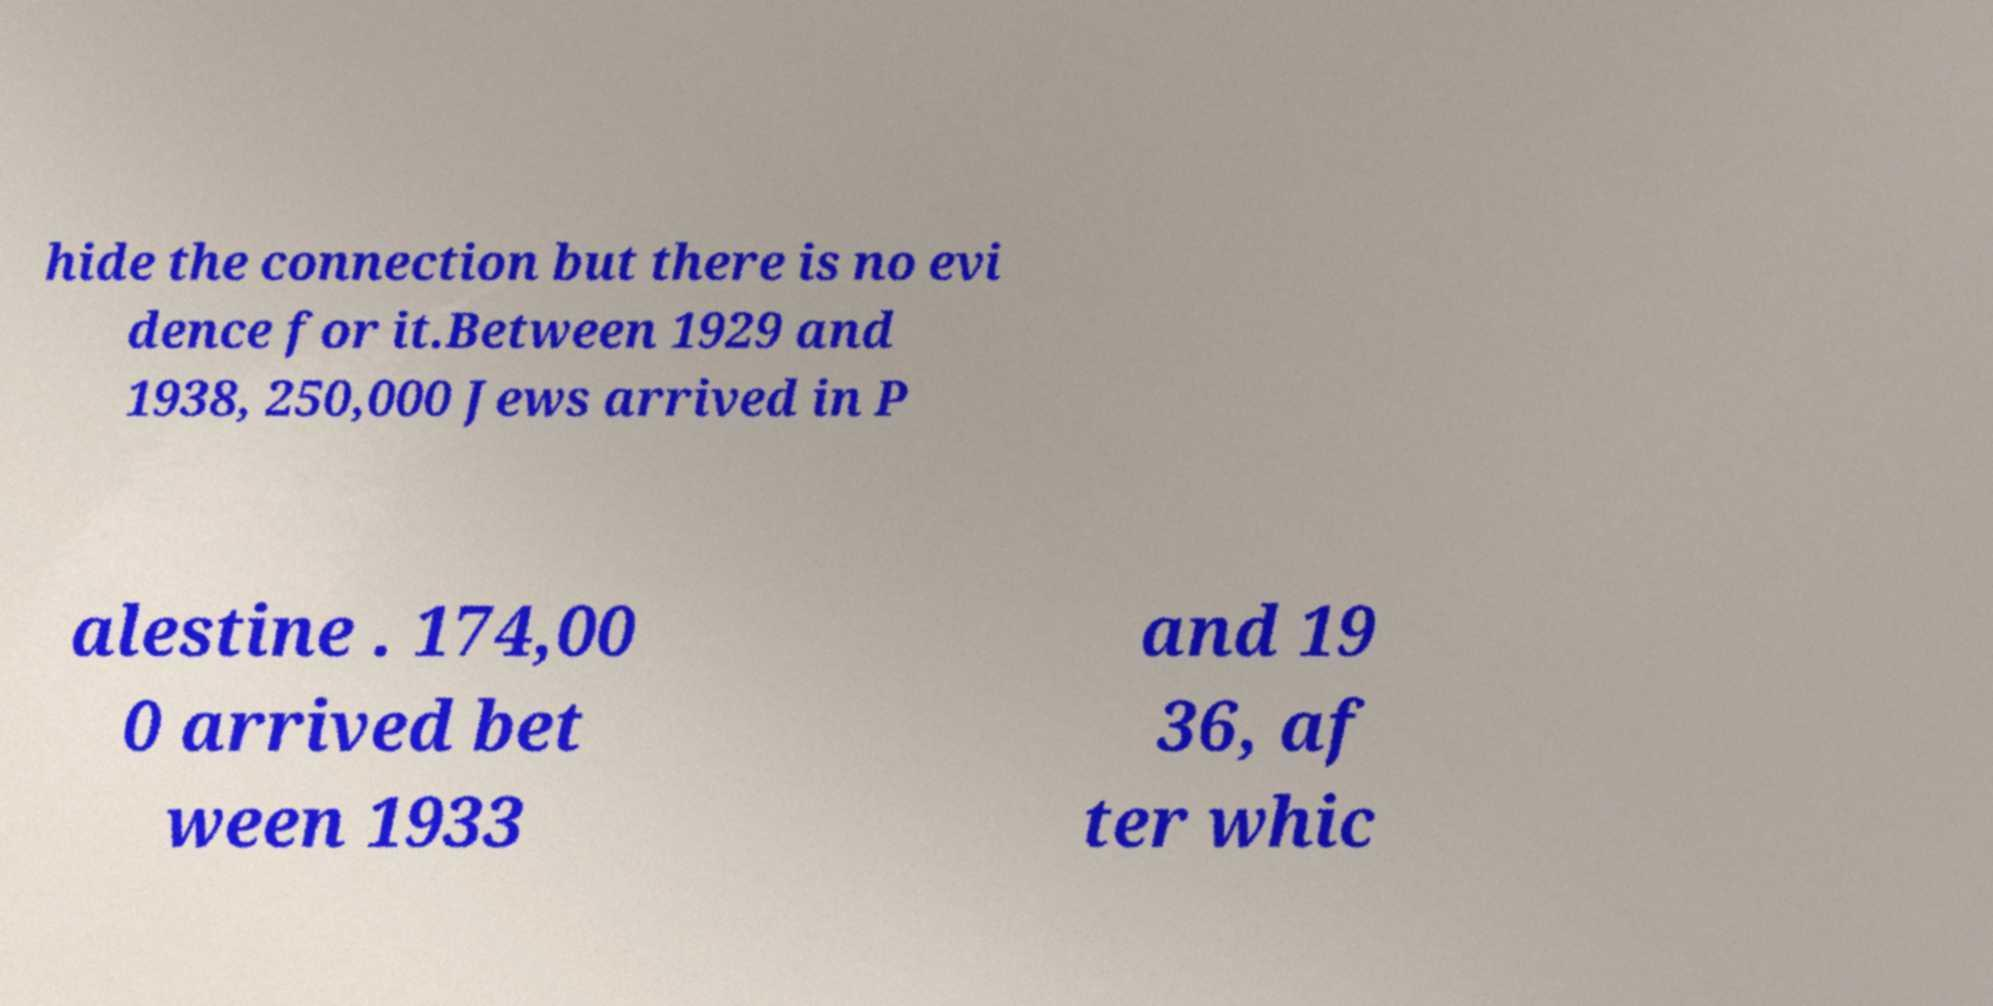There's text embedded in this image that I need extracted. Can you transcribe it verbatim? hide the connection but there is no evi dence for it.Between 1929 and 1938, 250,000 Jews arrived in P alestine . 174,00 0 arrived bet ween 1933 and 19 36, af ter whic 